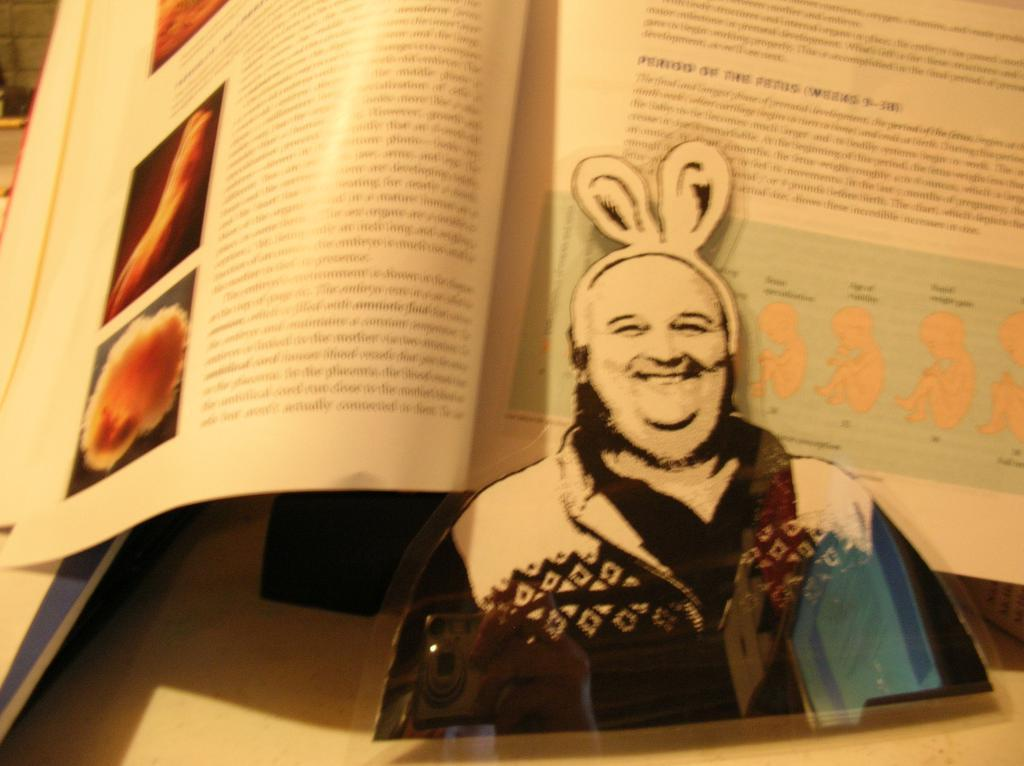What object can be seen in the image that is typically used for reading? There is a book in the image that is typically used for reading. What is depicted in the image besides the book? There is a picture of a man in the image. Where are the book and the picture of a man located in the image? Both the book and the picture of a man are placed on a table. Can you see the wren smiling in the image? There is no wren present in the image, and therefore it cannot be seen smiling. Is there a swing visible in the image? There is no swing present in the image. 